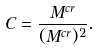Convert formula to latex. <formula><loc_0><loc_0><loc_500><loc_500>C = \frac { M ^ { c r } } { ( M ^ { c r } ) ^ { 2 } } .</formula> 